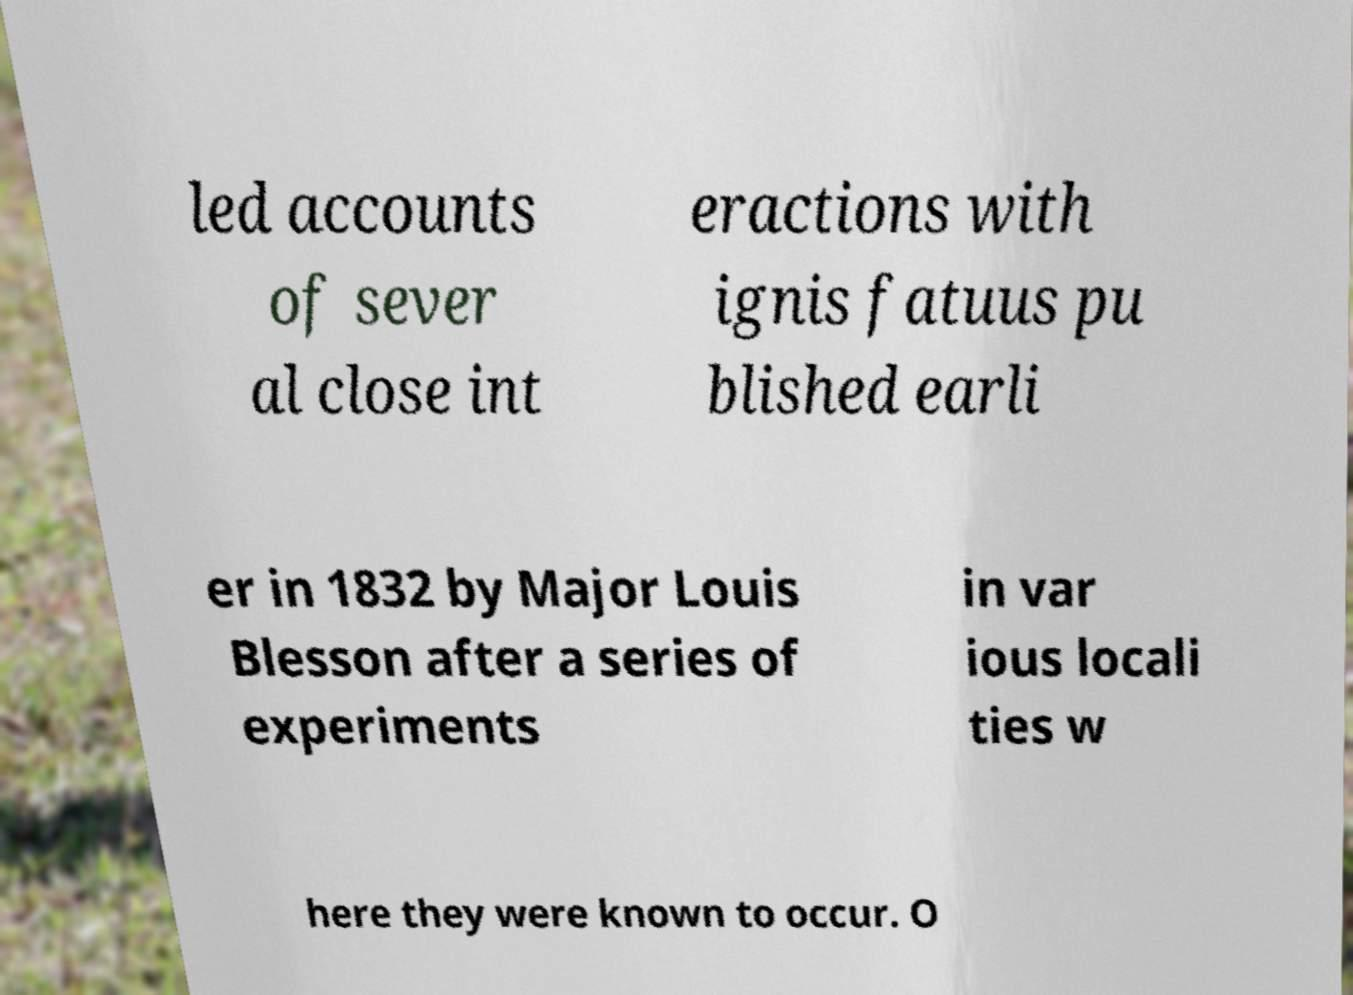There's text embedded in this image that I need extracted. Can you transcribe it verbatim? led accounts of sever al close int eractions with ignis fatuus pu blished earli er in 1832 by Major Louis Blesson after a series of experiments in var ious locali ties w here they were known to occur. O 